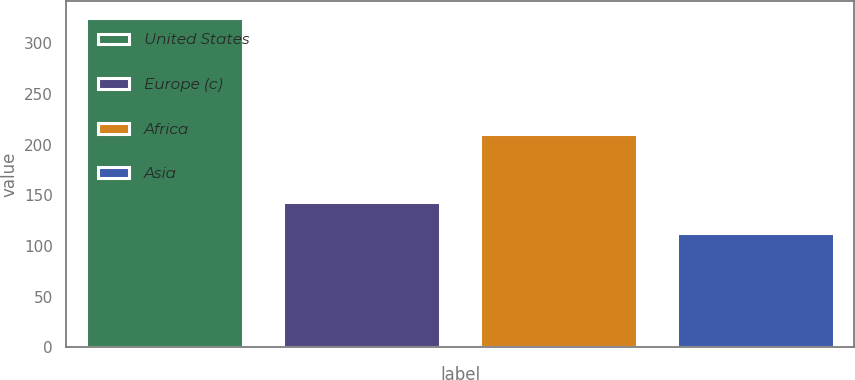<chart> <loc_0><loc_0><loc_500><loc_500><bar_chart><fcel>United States<fcel>Europe (c)<fcel>Africa<fcel>Asia<nl><fcel>325<fcel>143<fcel>210<fcel>113<nl></chart> 